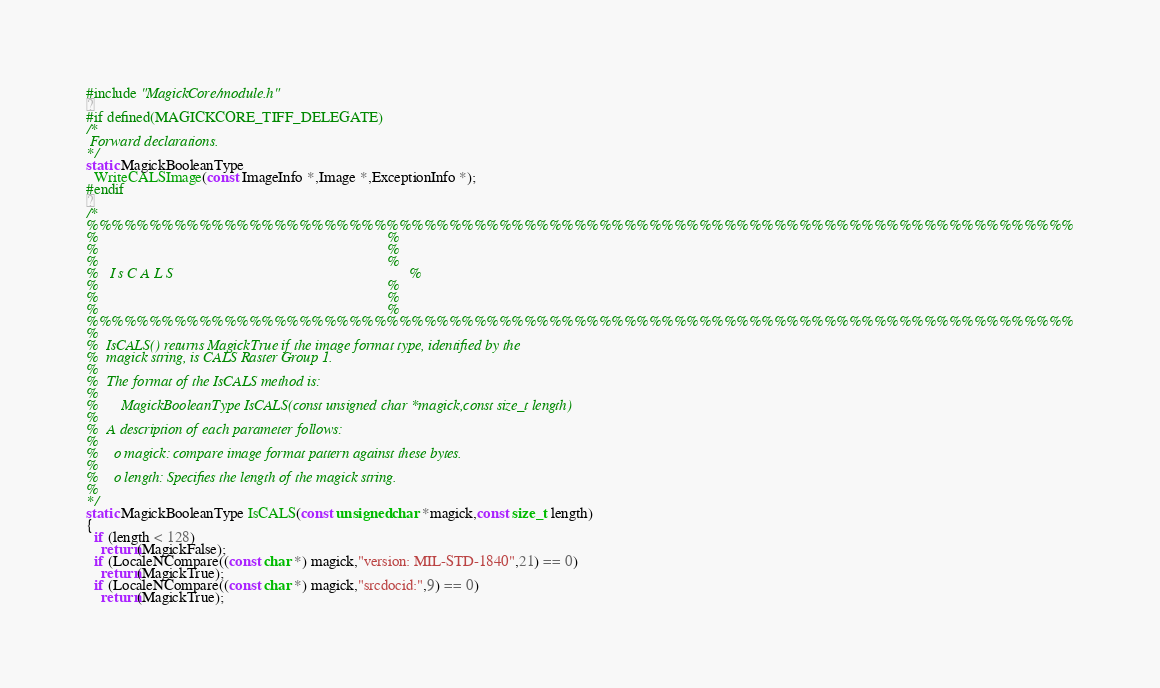<code> <loc_0><loc_0><loc_500><loc_500><_C_>#include "MagickCore/module.h"

#if defined(MAGICKCORE_TIFF_DELEGATE)
/*
 Forward declarations.
*/
static MagickBooleanType
  WriteCALSImage(const ImageInfo *,Image *,ExceptionInfo *);
#endif

/*
%%%%%%%%%%%%%%%%%%%%%%%%%%%%%%%%%%%%%%%%%%%%%%%%%%%%%%%%%%%%%%%%%%%%%%%%%%%%%%%
%                                                                             %
%                                                                             %
%                                                                             %
%   I s C A L S                                                               %
%                                                                             %
%                                                                             %
%                                                                             %
%%%%%%%%%%%%%%%%%%%%%%%%%%%%%%%%%%%%%%%%%%%%%%%%%%%%%%%%%%%%%%%%%%%%%%%%%%%%%%%
%
%  IsCALS() returns MagickTrue if the image format type, identified by the
%  magick string, is CALS Raster Group 1.
%
%  The format of the IsCALS method is:
%
%      MagickBooleanType IsCALS(const unsigned char *magick,const size_t length)
%
%  A description of each parameter follows:
%
%    o magick: compare image format pattern against these bytes.
%
%    o length: Specifies the length of the magick string.
%
*/
static MagickBooleanType IsCALS(const unsigned char *magick,const size_t length)
{
  if (length < 128)
    return(MagickFalse);
  if (LocaleNCompare((const char *) magick,"version: MIL-STD-1840",21) == 0)
    return(MagickTrue);
  if (LocaleNCompare((const char *) magick,"srcdocid:",9) == 0)
    return(MagickTrue);</code> 